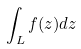Convert formula to latex. <formula><loc_0><loc_0><loc_500><loc_500>\int _ { L } f ( z ) d z</formula> 